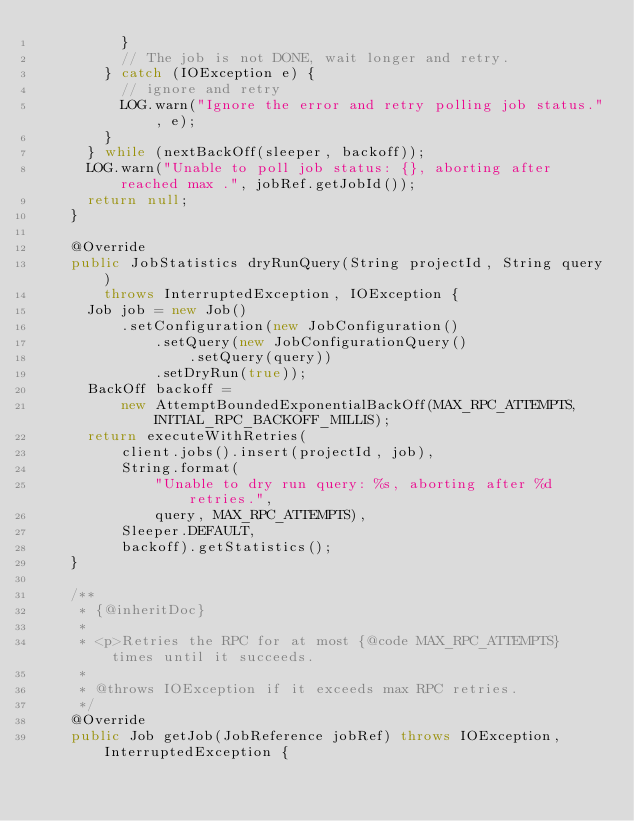<code> <loc_0><loc_0><loc_500><loc_500><_Java_>          }
          // The job is not DONE, wait longer and retry.
        } catch (IOException e) {
          // ignore and retry
          LOG.warn("Ignore the error and retry polling job status.", e);
        }
      } while (nextBackOff(sleeper, backoff));
      LOG.warn("Unable to poll job status: {}, aborting after reached max .", jobRef.getJobId());
      return null;
    }

    @Override
    public JobStatistics dryRunQuery(String projectId, String query)
        throws InterruptedException, IOException {
      Job job = new Job()
          .setConfiguration(new JobConfiguration()
              .setQuery(new JobConfigurationQuery()
                  .setQuery(query))
              .setDryRun(true));
      BackOff backoff =
          new AttemptBoundedExponentialBackOff(MAX_RPC_ATTEMPTS, INITIAL_RPC_BACKOFF_MILLIS);
      return executeWithRetries(
          client.jobs().insert(projectId, job),
          String.format(
              "Unable to dry run query: %s, aborting after %d retries.",
              query, MAX_RPC_ATTEMPTS),
          Sleeper.DEFAULT,
          backoff).getStatistics();
    }

    /**
     * {@inheritDoc}
     *
     * <p>Retries the RPC for at most {@code MAX_RPC_ATTEMPTS} times until it succeeds.
     *
     * @throws IOException if it exceeds max RPC retries.
     */
    @Override
    public Job getJob(JobReference jobRef) throws IOException, InterruptedException {</code> 